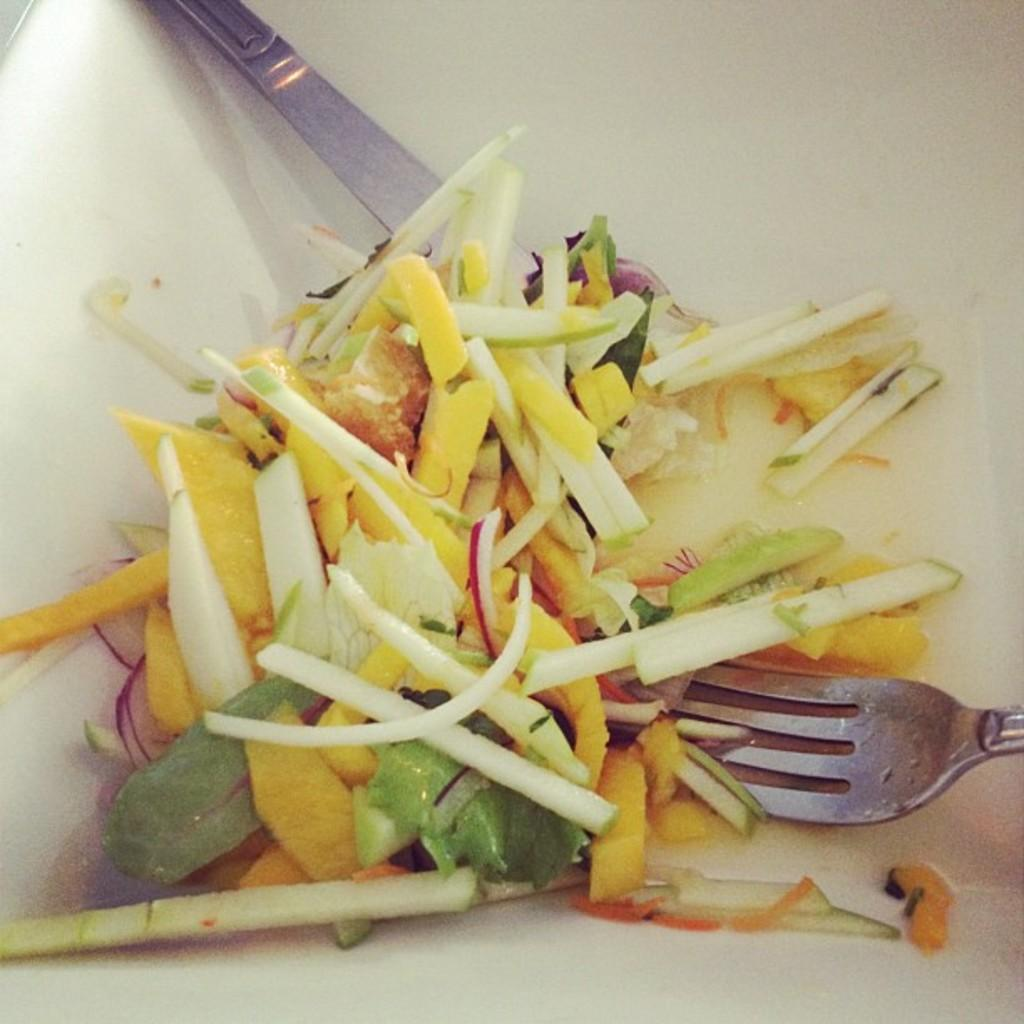What is inside the container in the image? There is food in a container in the image. What utensils are visible in the image? There is a fork and a spoon in the image. Where is the nearest mailbox to the container in the image? There is no mailbox present in the image, so it cannot be determined from the image. 